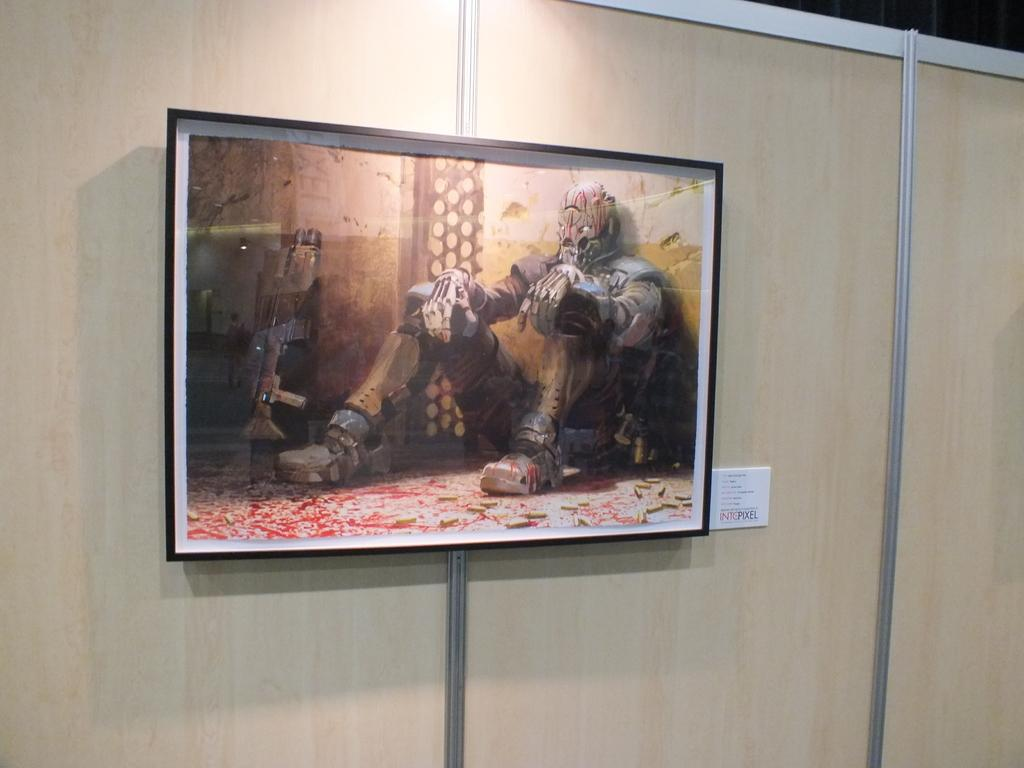What object can be seen in the image that typically holds a photograph? There is a photo frame in the image. Where is the photo frame located? The photo frame is attached to a wooden wall. What is the person in the image doing? The person is wearing different costumes and sitting on the floor. What can be seen in the image that might be used for self-defense or hunting? There is a weapon visible in the image. What type of scarf is the person wearing in the image? There is no scarf visible in the image; the person is wearing different costumes. What caption is written on the photo frame in the image? There is no caption visible on the photo frame in the image; it is simply holding a photograph. 